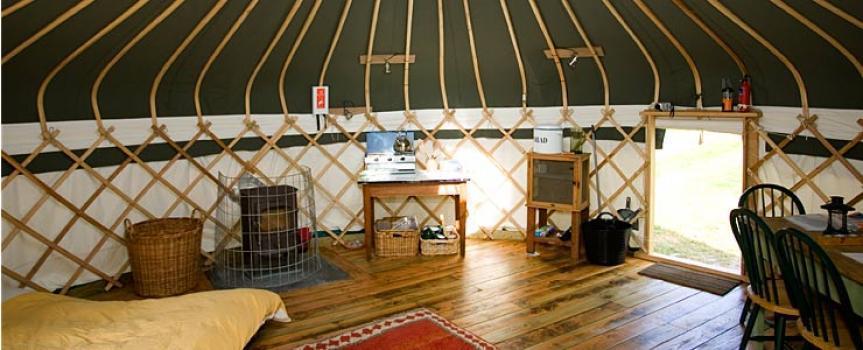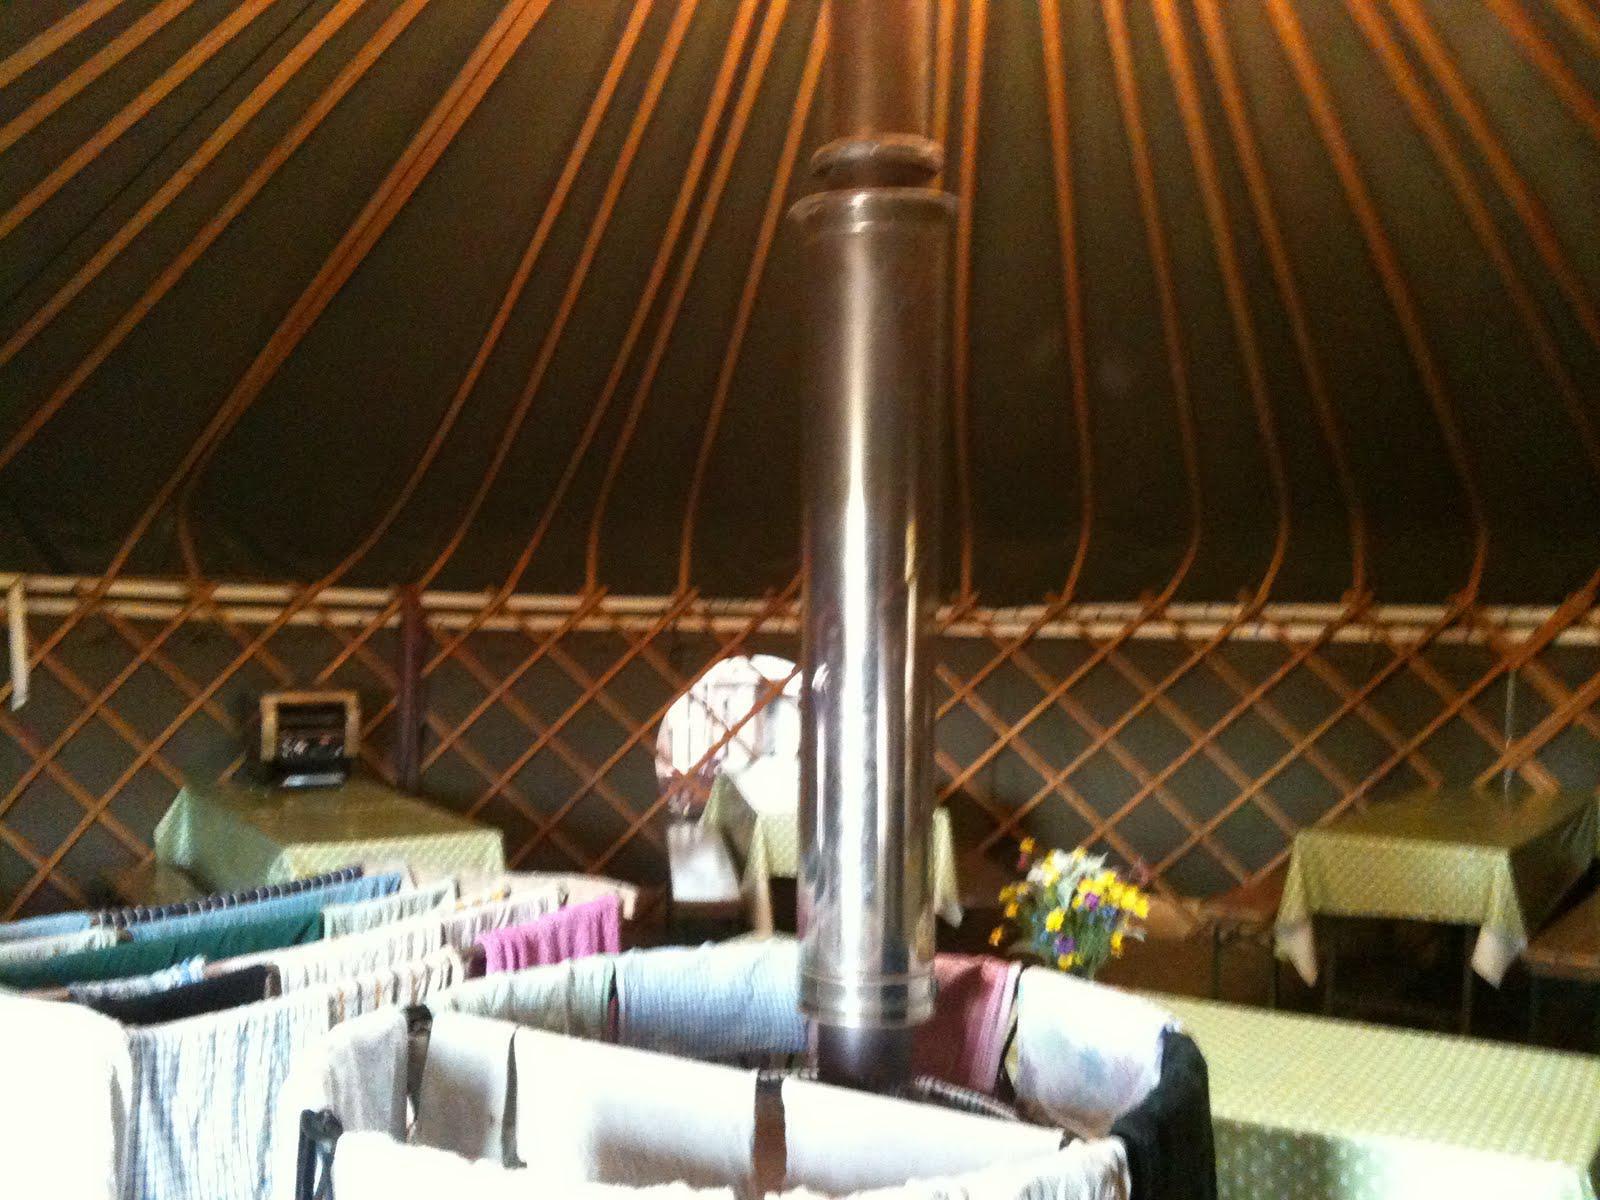The first image is the image on the left, the second image is the image on the right. Examine the images to the left and right. Is the description "The door opens to the living area of the yurt in one of the images." accurate? Answer yes or no. Yes. The first image is the image on the left, the second image is the image on the right. For the images displayed, is the sentence "Left and right images feature a bedroom inside a yurt, and at least one bedroom features a bed flanked by wooden nightstands." factually correct? Answer yes or no. No. 